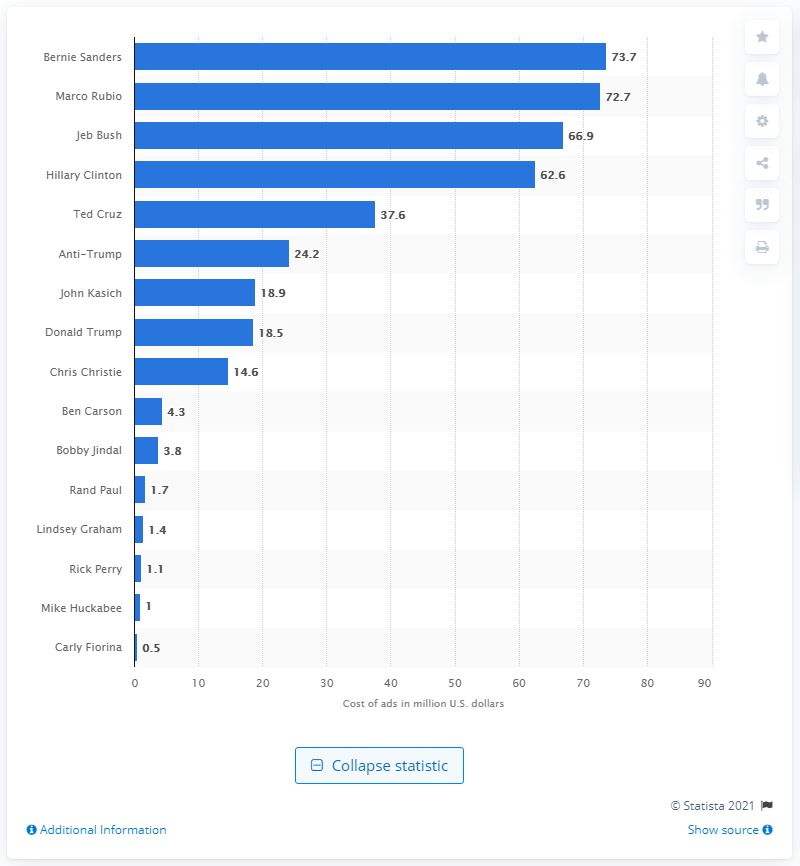List a handful of essential elements in this visual. Bernie Sanders spent 73.7 million dollars on advertising during the 2016 U.S. presidential election. 